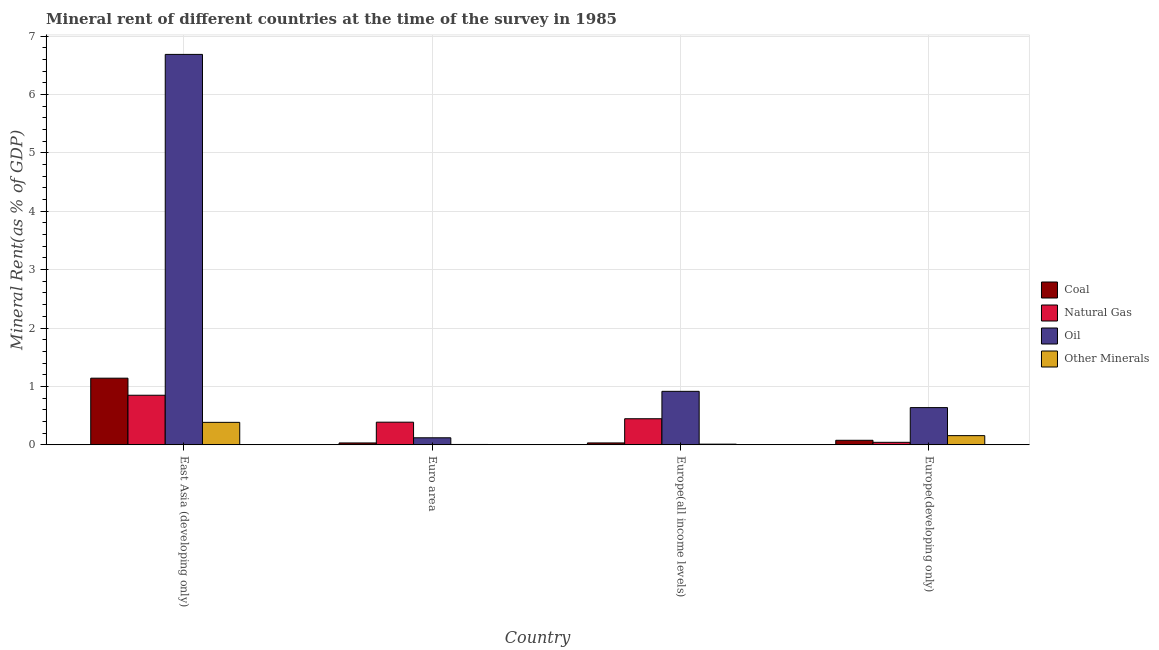How many different coloured bars are there?
Your answer should be compact. 4. How many bars are there on the 2nd tick from the left?
Your answer should be very brief. 4. How many bars are there on the 3rd tick from the right?
Provide a succinct answer. 4. What is the label of the 3rd group of bars from the left?
Ensure brevity in your answer.  Europe(all income levels). What is the oil rent in Europe(all income levels)?
Give a very brief answer. 0.92. Across all countries, what is the maximum  rent of other minerals?
Offer a very short reply. 0.38. Across all countries, what is the minimum oil rent?
Give a very brief answer. 0.12. In which country was the  rent of other minerals maximum?
Provide a succinct answer. East Asia (developing only). In which country was the  rent of other minerals minimum?
Keep it short and to the point. Euro area. What is the total natural gas rent in the graph?
Your answer should be very brief. 1.72. What is the difference between the coal rent in Euro area and that in Europe(developing only)?
Provide a short and direct response. -0.05. What is the difference between the oil rent in Euro area and the coal rent in Europe(all income levels)?
Offer a very short reply. 0.09. What is the average oil rent per country?
Your answer should be very brief. 2.09. What is the difference between the natural gas rent and  rent of other minerals in East Asia (developing only)?
Provide a short and direct response. 0.46. In how many countries, is the  rent of other minerals greater than 1 %?
Your answer should be compact. 0. What is the ratio of the oil rent in Europe(all income levels) to that in Europe(developing only)?
Keep it short and to the point. 1.44. Is the difference between the coal rent in East Asia (developing only) and Euro area greater than the difference between the natural gas rent in East Asia (developing only) and Euro area?
Your answer should be very brief. Yes. What is the difference between the highest and the second highest coal rent?
Give a very brief answer. 1.06. What is the difference between the highest and the lowest  rent of other minerals?
Make the answer very short. 0.38. In how many countries, is the  rent of other minerals greater than the average  rent of other minerals taken over all countries?
Offer a very short reply. 2. What does the 1st bar from the left in East Asia (developing only) represents?
Provide a succinct answer. Coal. What does the 3rd bar from the right in East Asia (developing only) represents?
Provide a short and direct response. Natural Gas. How many countries are there in the graph?
Provide a succinct answer. 4. Are the values on the major ticks of Y-axis written in scientific E-notation?
Ensure brevity in your answer.  No. Does the graph contain grids?
Offer a terse response. Yes. How many legend labels are there?
Offer a very short reply. 4. How are the legend labels stacked?
Offer a terse response. Vertical. What is the title of the graph?
Keep it short and to the point. Mineral rent of different countries at the time of the survey in 1985. Does "Gender equality" appear as one of the legend labels in the graph?
Your answer should be very brief. No. What is the label or title of the Y-axis?
Offer a terse response. Mineral Rent(as % of GDP). What is the Mineral Rent(as % of GDP) in Coal in East Asia (developing only)?
Provide a succinct answer. 1.14. What is the Mineral Rent(as % of GDP) of Natural Gas in East Asia (developing only)?
Provide a short and direct response. 0.85. What is the Mineral Rent(as % of GDP) in Oil in East Asia (developing only)?
Make the answer very short. 6.69. What is the Mineral Rent(as % of GDP) in Other Minerals in East Asia (developing only)?
Your answer should be compact. 0.38. What is the Mineral Rent(as % of GDP) of Coal in Euro area?
Your answer should be very brief. 0.03. What is the Mineral Rent(as % of GDP) in Natural Gas in Euro area?
Make the answer very short. 0.39. What is the Mineral Rent(as % of GDP) of Oil in Euro area?
Give a very brief answer. 0.12. What is the Mineral Rent(as % of GDP) in Other Minerals in Euro area?
Give a very brief answer. 0.01. What is the Mineral Rent(as % of GDP) in Coal in Europe(all income levels)?
Your response must be concise. 0.03. What is the Mineral Rent(as % of GDP) of Natural Gas in Europe(all income levels)?
Give a very brief answer. 0.45. What is the Mineral Rent(as % of GDP) in Oil in Europe(all income levels)?
Offer a very short reply. 0.92. What is the Mineral Rent(as % of GDP) in Other Minerals in Europe(all income levels)?
Offer a terse response. 0.01. What is the Mineral Rent(as % of GDP) of Coal in Europe(developing only)?
Offer a very short reply. 0.08. What is the Mineral Rent(as % of GDP) of Natural Gas in Europe(developing only)?
Offer a terse response. 0.04. What is the Mineral Rent(as % of GDP) in Oil in Europe(developing only)?
Make the answer very short. 0.64. What is the Mineral Rent(as % of GDP) in Other Minerals in Europe(developing only)?
Provide a succinct answer. 0.16. Across all countries, what is the maximum Mineral Rent(as % of GDP) of Coal?
Provide a succinct answer. 1.14. Across all countries, what is the maximum Mineral Rent(as % of GDP) of Natural Gas?
Give a very brief answer. 0.85. Across all countries, what is the maximum Mineral Rent(as % of GDP) of Oil?
Keep it short and to the point. 6.69. Across all countries, what is the maximum Mineral Rent(as % of GDP) in Other Minerals?
Your response must be concise. 0.38. Across all countries, what is the minimum Mineral Rent(as % of GDP) in Coal?
Provide a short and direct response. 0.03. Across all countries, what is the minimum Mineral Rent(as % of GDP) of Natural Gas?
Make the answer very short. 0.04. Across all countries, what is the minimum Mineral Rent(as % of GDP) of Oil?
Your answer should be very brief. 0.12. Across all countries, what is the minimum Mineral Rent(as % of GDP) in Other Minerals?
Provide a short and direct response. 0.01. What is the total Mineral Rent(as % of GDP) of Coal in the graph?
Provide a succinct answer. 1.28. What is the total Mineral Rent(as % of GDP) of Natural Gas in the graph?
Give a very brief answer. 1.72. What is the total Mineral Rent(as % of GDP) in Oil in the graph?
Provide a succinct answer. 8.36. What is the total Mineral Rent(as % of GDP) of Other Minerals in the graph?
Provide a short and direct response. 0.56. What is the difference between the Mineral Rent(as % of GDP) in Coal in East Asia (developing only) and that in Euro area?
Provide a succinct answer. 1.11. What is the difference between the Mineral Rent(as % of GDP) of Natural Gas in East Asia (developing only) and that in Euro area?
Your response must be concise. 0.46. What is the difference between the Mineral Rent(as % of GDP) of Oil in East Asia (developing only) and that in Euro area?
Keep it short and to the point. 6.57. What is the difference between the Mineral Rent(as % of GDP) in Other Minerals in East Asia (developing only) and that in Euro area?
Keep it short and to the point. 0.38. What is the difference between the Mineral Rent(as % of GDP) in Coal in East Asia (developing only) and that in Europe(all income levels)?
Provide a succinct answer. 1.11. What is the difference between the Mineral Rent(as % of GDP) of Natural Gas in East Asia (developing only) and that in Europe(all income levels)?
Your answer should be compact. 0.4. What is the difference between the Mineral Rent(as % of GDP) of Oil in East Asia (developing only) and that in Europe(all income levels)?
Give a very brief answer. 5.77. What is the difference between the Mineral Rent(as % of GDP) of Other Minerals in East Asia (developing only) and that in Europe(all income levels)?
Your answer should be compact. 0.37. What is the difference between the Mineral Rent(as % of GDP) of Coal in East Asia (developing only) and that in Europe(developing only)?
Your answer should be very brief. 1.06. What is the difference between the Mineral Rent(as % of GDP) in Natural Gas in East Asia (developing only) and that in Europe(developing only)?
Your response must be concise. 0.81. What is the difference between the Mineral Rent(as % of GDP) of Oil in East Asia (developing only) and that in Europe(developing only)?
Keep it short and to the point. 6.05. What is the difference between the Mineral Rent(as % of GDP) in Other Minerals in East Asia (developing only) and that in Europe(developing only)?
Your answer should be compact. 0.23. What is the difference between the Mineral Rent(as % of GDP) of Coal in Euro area and that in Europe(all income levels)?
Ensure brevity in your answer.  -0. What is the difference between the Mineral Rent(as % of GDP) in Natural Gas in Euro area and that in Europe(all income levels)?
Give a very brief answer. -0.06. What is the difference between the Mineral Rent(as % of GDP) of Oil in Euro area and that in Europe(all income levels)?
Keep it short and to the point. -0.8. What is the difference between the Mineral Rent(as % of GDP) of Other Minerals in Euro area and that in Europe(all income levels)?
Provide a short and direct response. -0.01. What is the difference between the Mineral Rent(as % of GDP) of Coal in Euro area and that in Europe(developing only)?
Your answer should be very brief. -0.05. What is the difference between the Mineral Rent(as % of GDP) of Natural Gas in Euro area and that in Europe(developing only)?
Provide a succinct answer. 0.34. What is the difference between the Mineral Rent(as % of GDP) in Oil in Euro area and that in Europe(developing only)?
Provide a succinct answer. -0.52. What is the difference between the Mineral Rent(as % of GDP) in Other Minerals in Euro area and that in Europe(developing only)?
Your answer should be compact. -0.15. What is the difference between the Mineral Rent(as % of GDP) of Coal in Europe(all income levels) and that in Europe(developing only)?
Provide a succinct answer. -0.05. What is the difference between the Mineral Rent(as % of GDP) of Natural Gas in Europe(all income levels) and that in Europe(developing only)?
Your answer should be very brief. 0.4. What is the difference between the Mineral Rent(as % of GDP) of Oil in Europe(all income levels) and that in Europe(developing only)?
Offer a very short reply. 0.28. What is the difference between the Mineral Rent(as % of GDP) of Other Minerals in Europe(all income levels) and that in Europe(developing only)?
Your answer should be compact. -0.15. What is the difference between the Mineral Rent(as % of GDP) in Coal in East Asia (developing only) and the Mineral Rent(as % of GDP) in Natural Gas in Euro area?
Your answer should be compact. 0.75. What is the difference between the Mineral Rent(as % of GDP) in Coal in East Asia (developing only) and the Mineral Rent(as % of GDP) in Oil in Euro area?
Ensure brevity in your answer.  1.02. What is the difference between the Mineral Rent(as % of GDP) in Coal in East Asia (developing only) and the Mineral Rent(as % of GDP) in Other Minerals in Euro area?
Make the answer very short. 1.13. What is the difference between the Mineral Rent(as % of GDP) in Natural Gas in East Asia (developing only) and the Mineral Rent(as % of GDP) in Oil in Euro area?
Give a very brief answer. 0.73. What is the difference between the Mineral Rent(as % of GDP) of Natural Gas in East Asia (developing only) and the Mineral Rent(as % of GDP) of Other Minerals in Euro area?
Your answer should be very brief. 0.84. What is the difference between the Mineral Rent(as % of GDP) in Oil in East Asia (developing only) and the Mineral Rent(as % of GDP) in Other Minerals in Euro area?
Your answer should be compact. 6.68. What is the difference between the Mineral Rent(as % of GDP) of Coal in East Asia (developing only) and the Mineral Rent(as % of GDP) of Natural Gas in Europe(all income levels)?
Your answer should be very brief. 0.69. What is the difference between the Mineral Rent(as % of GDP) of Coal in East Asia (developing only) and the Mineral Rent(as % of GDP) of Oil in Europe(all income levels)?
Offer a very short reply. 0.23. What is the difference between the Mineral Rent(as % of GDP) of Coal in East Asia (developing only) and the Mineral Rent(as % of GDP) of Other Minerals in Europe(all income levels)?
Provide a short and direct response. 1.13. What is the difference between the Mineral Rent(as % of GDP) in Natural Gas in East Asia (developing only) and the Mineral Rent(as % of GDP) in Oil in Europe(all income levels)?
Ensure brevity in your answer.  -0.07. What is the difference between the Mineral Rent(as % of GDP) in Natural Gas in East Asia (developing only) and the Mineral Rent(as % of GDP) in Other Minerals in Europe(all income levels)?
Provide a succinct answer. 0.84. What is the difference between the Mineral Rent(as % of GDP) of Oil in East Asia (developing only) and the Mineral Rent(as % of GDP) of Other Minerals in Europe(all income levels)?
Your answer should be very brief. 6.67. What is the difference between the Mineral Rent(as % of GDP) of Coal in East Asia (developing only) and the Mineral Rent(as % of GDP) of Natural Gas in Europe(developing only)?
Offer a very short reply. 1.1. What is the difference between the Mineral Rent(as % of GDP) in Coal in East Asia (developing only) and the Mineral Rent(as % of GDP) in Oil in Europe(developing only)?
Ensure brevity in your answer.  0.5. What is the difference between the Mineral Rent(as % of GDP) of Coal in East Asia (developing only) and the Mineral Rent(as % of GDP) of Other Minerals in Europe(developing only)?
Offer a very short reply. 0.98. What is the difference between the Mineral Rent(as % of GDP) of Natural Gas in East Asia (developing only) and the Mineral Rent(as % of GDP) of Oil in Europe(developing only)?
Your answer should be very brief. 0.21. What is the difference between the Mineral Rent(as % of GDP) in Natural Gas in East Asia (developing only) and the Mineral Rent(as % of GDP) in Other Minerals in Europe(developing only)?
Give a very brief answer. 0.69. What is the difference between the Mineral Rent(as % of GDP) of Oil in East Asia (developing only) and the Mineral Rent(as % of GDP) of Other Minerals in Europe(developing only)?
Provide a short and direct response. 6.53. What is the difference between the Mineral Rent(as % of GDP) in Coal in Euro area and the Mineral Rent(as % of GDP) in Natural Gas in Europe(all income levels)?
Your answer should be compact. -0.41. What is the difference between the Mineral Rent(as % of GDP) in Coal in Euro area and the Mineral Rent(as % of GDP) in Oil in Europe(all income levels)?
Ensure brevity in your answer.  -0.88. What is the difference between the Mineral Rent(as % of GDP) in Coal in Euro area and the Mineral Rent(as % of GDP) in Other Minerals in Europe(all income levels)?
Your response must be concise. 0.02. What is the difference between the Mineral Rent(as % of GDP) of Natural Gas in Euro area and the Mineral Rent(as % of GDP) of Oil in Europe(all income levels)?
Offer a very short reply. -0.53. What is the difference between the Mineral Rent(as % of GDP) of Natural Gas in Euro area and the Mineral Rent(as % of GDP) of Other Minerals in Europe(all income levels)?
Keep it short and to the point. 0.38. What is the difference between the Mineral Rent(as % of GDP) of Oil in Euro area and the Mineral Rent(as % of GDP) of Other Minerals in Europe(all income levels)?
Your answer should be compact. 0.11. What is the difference between the Mineral Rent(as % of GDP) of Coal in Euro area and the Mineral Rent(as % of GDP) of Natural Gas in Europe(developing only)?
Ensure brevity in your answer.  -0.01. What is the difference between the Mineral Rent(as % of GDP) in Coal in Euro area and the Mineral Rent(as % of GDP) in Oil in Europe(developing only)?
Your answer should be very brief. -0.61. What is the difference between the Mineral Rent(as % of GDP) of Coal in Euro area and the Mineral Rent(as % of GDP) of Other Minerals in Europe(developing only)?
Your answer should be compact. -0.13. What is the difference between the Mineral Rent(as % of GDP) in Natural Gas in Euro area and the Mineral Rent(as % of GDP) in Oil in Europe(developing only)?
Your response must be concise. -0.25. What is the difference between the Mineral Rent(as % of GDP) of Natural Gas in Euro area and the Mineral Rent(as % of GDP) of Other Minerals in Europe(developing only)?
Ensure brevity in your answer.  0.23. What is the difference between the Mineral Rent(as % of GDP) of Oil in Euro area and the Mineral Rent(as % of GDP) of Other Minerals in Europe(developing only)?
Keep it short and to the point. -0.04. What is the difference between the Mineral Rent(as % of GDP) in Coal in Europe(all income levels) and the Mineral Rent(as % of GDP) in Natural Gas in Europe(developing only)?
Give a very brief answer. -0.01. What is the difference between the Mineral Rent(as % of GDP) of Coal in Europe(all income levels) and the Mineral Rent(as % of GDP) of Oil in Europe(developing only)?
Your answer should be compact. -0.6. What is the difference between the Mineral Rent(as % of GDP) in Coal in Europe(all income levels) and the Mineral Rent(as % of GDP) in Other Minerals in Europe(developing only)?
Provide a succinct answer. -0.13. What is the difference between the Mineral Rent(as % of GDP) in Natural Gas in Europe(all income levels) and the Mineral Rent(as % of GDP) in Oil in Europe(developing only)?
Give a very brief answer. -0.19. What is the difference between the Mineral Rent(as % of GDP) of Natural Gas in Europe(all income levels) and the Mineral Rent(as % of GDP) of Other Minerals in Europe(developing only)?
Keep it short and to the point. 0.29. What is the difference between the Mineral Rent(as % of GDP) in Oil in Europe(all income levels) and the Mineral Rent(as % of GDP) in Other Minerals in Europe(developing only)?
Give a very brief answer. 0.76. What is the average Mineral Rent(as % of GDP) in Coal per country?
Your response must be concise. 0.32. What is the average Mineral Rent(as % of GDP) in Natural Gas per country?
Ensure brevity in your answer.  0.43. What is the average Mineral Rent(as % of GDP) in Oil per country?
Offer a terse response. 2.09. What is the average Mineral Rent(as % of GDP) of Other Minerals per country?
Give a very brief answer. 0.14. What is the difference between the Mineral Rent(as % of GDP) of Coal and Mineral Rent(as % of GDP) of Natural Gas in East Asia (developing only)?
Your answer should be very brief. 0.29. What is the difference between the Mineral Rent(as % of GDP) of Coal and Mineral Rent(as % of GDP) of Oil in East Asia (developing only)?
Provide a succinct answer. -5.54. What is the difference between the Mineral Rent(as % of GDP) of Coal and Mineral Rent(as % of GDP) of Other Minerals in East Asia (developing only)?
Your answer should be very brief. 0.76. What is the difference between the Mineral Rent(as % of GDP) of Natural Gas and Mineral Rent(as % of GDP) of Oil in East Asia (developing only)?
Your answer should be very brief. -5.84. What is the difference between the Mineral Rent(as % of GDP) of Natural Gas and Mineral Rent(as % of GDP) of Other Minerals in East Asia (developing only)?
Provide a succinct answer. 0.46. What is the difference between the Mineral Rent(as % of GDP) of Oil and Mineral Rent(as % of GDP) of Other Minerals in East Asia (developing only)?
Offer a terse response. 6.3. What is the difference between the Mineral Rent(as % of GDP) of Coal and Mineral Rent(as % of GDP) of Natural Gas in Euro area?
Give a very brief answer. -0.36. What is the difference between the Mineral Rent(as % of GDP) of Coal and Mineral Rent(as % of GDP) of Oil in Euro area?
Your response must be concise. -0.09. What is the difference between the Mineral Rent(as % of GDP) in Coal and Mineral Rent(as % of GDP) in Other Minerals in Euro area?
Give a very brief answer. 0.03. What is the difference between the Mineral Rent(as % of GDP) in Natural Gas and Mineral Rent(as % of GDP) in Oil in Euro area?
Give a very brief answer. 0.27. What is the difference between the Mineral Rent(as % of GDP) in Natural Gas and Mineral Rent(as % of GDP) in Other Minerals in Euro area?
Your answer should be very brief. 0.38. What is the difference between the Mineral Rent(as % of GDP) in Oil and Mineral Rent(as % of GDP) in Other Minerals in Euro area?
Provide a succinct answer. 0.11. What is the difference between the Mineral Rent(as % of GDP) in Coal and Mineral Rent(as % of GDP) in Natural Gas in Europe(all income levels)?
Your answer should be compact. -0.41. What is the difference between the Mineral Rent(as % of GDP) of Coal and Mineral Rent(as % of GDP) of Oil in Europe(all income levels)?
Your answer should be very brief. -0.88. What is the difference between the Mineral Rent(as % of GDP) in Coal and Mineral Rent(as % of GDP) in Other Minerals in Europe(all income levels)?
Your answer should be very brief. 0.02. What is the difference between the Mineral Rent(as % of GDP) of Natural Gas and Mineral Rent(as % of GDP) of Oil in Europe(all income levels)?
Offer a very short reply. -0.47. What is the difference between the Mineral Rent(as % of GDP) in Natural Gas and Mineral Rent(as % of GDP) in Other Minerals in Europe(all income levels)?
Keep it short and to the point. 0.44. What is the difference between the Mineral Rent(as % of GDP) of Oil and Mineral Rent(as % of GDP) of Other Minerals in Europe(all income levels)?
Offer a terse response. 0.9. What is the difference between the Mineral Rent(as % of GDP) of Coal and Mineral Rent(as % of GDP) of Natural Gas in Europe(developing only)?
Make the answer very short. 0.03. What is the difference between the Mineral Rent(as % of GDP) in Coal and Mineral Rent(as % of GDP) in Oil in Europe(developing only)?
Ensure brevity in your answer.  -0.56. What is the difference between the Mineral Rent(as % of GDP) of Coal and Mineral Rent(as % of GDP) of Other Minerals in Europe(developing only)?
Ensure brevity in your answer.  -0.08. What is the difference between the Mineral Rent(as % of GDP) in Natural Gas and Mineral Rent(as % of GDP) in Oil in Europe(developing only)?
Provide a succinct answer. -0.59. What is the difference between the Mineral Rent(as % of GDP) of Natural Gas and Mineral Rent(as % of GDP) of Other Minerals in Europe(developing only)?
Your answer should be very brief. -0.11. What is the difference between the Mineral Rent(as % of GDP) of Oil and Mineral Rent(as % of GDP) of Other Minerals in Europe(developing only)?
Make the answer very short. 0.48. What is the ratio of the Mineral Rent(as % of GDP) of Coal in East Asia (developing only) to that in Euro area?
Ensure brevity in your answer.  36.03. What is the ratio of the Mineral Rent(as % of GDP) in Natural Gas in East Asia (developing only) to that in Euro area?
Your response must be concise. 2.19. What is the ratio of the Mineral Rent(as % of GDP) of Oil in East Asia (developing only) to that in Euro area?
Ensure brevity in your answer.  55.65. What is the ratio of the Mineral Rent(as % of GDP) in Other Minerals in East Asia (developing only) to that in Euro area?
Ensure brevity in your answer.  65.82. What is the ratio of the Mineral Rent(as % of GDP) of Coal in East Asia (developing only) to that in Europe(all income levels)?
Your answer should be compact. 35.66. What is the ratio of the Mineral Rent(as % of GDP) in Natural Gas in East Asia (developing only) to that in Europe(all income levels)?
Keep it short and to the point. 1.9. What is the ratio of the Mineral Rent(as % of GDP) in Oil in East Asia (developing only) to that in Europe(all income levels)?
Your answer should be very brief. 7.3. What is the ratio of the Mineral Rent(as % of GDP) of Other Minerals in East Asia (developing only) to that in Europe(all income levels)?
Offer a terse response. 34.87. What is the ratio of the Mineral Rent(as % of GDP) of Coal in East Asia (developing only) to that in Europe(developing only)?
Keep it short and to the point. 14.76. What is the ratio of the Mineral Rent(as % of GDP) of Natural Gas in East Asia (developing only) to that in Europe(developing only)?
Offer a terse response. 20. What is the ratio of the Mineral Rent(as % of GDP) in Oil in East Asia (developing only) to that in Europe(developing only)?
Offer a terse response. 10.5. What is the ratio of the Mineral Rent(as % of GDP) of Other Minerals in East Asia (developing only) to that in Europe(developing only)?
Give a very brief answer. 2.45. What is the ratio of the Mineral Rent(as % of GDP) in Natural Gas in Euro area to that in Europe(all income levels)?
Ensure brevity in your answer.  0.87. What is the ratio of the Mineral Rent(as % of GDP) in Oil in Euro area to that in Europe(all income levels)?
Your answer should be very brief. 0.13. What is the ratio of the Mineral Rent(as % of GDP) in Other Minerals in Euro area to that in Europe(all income levels)?
Offer a very short reply. 0.53. What is the ratio of the Mineral Rent(as % of GDP) in Coal in Euro area to that in Europe(developing only)?
Give a very brief answer. 0.41. What is the ratio of the Mineral Rent(as % of GDP) of Natural Gas in Euro area to that in Europe(developing only)?
Ensure brevity in your answer.  9.13. What is the ratio of the Mineral Rent(as % of GDP) of Oil in Euro area to that in Europe(developing only)?
Offer a very short reply. 0.19. What is the ratio of the Mineral Rent(as % of GDP) in Other Minerals in Euro area to that in Europe(developing only)?
Your response must be concise. 0.04. What is the ratio of the Mineral Rent(as % of GDP) of Coal in Europe(all income levels) to that in Europe(developing only)?
Give a very brief answer. 0.41. What is the ratio of the Mineral Rent(as % of GDP) in Natural Gas in Europe(all income levels) to that in Europe(developing only)?
Keep it short and to the point. 10.52. What is the ratio of the Mineral Rent(as % of GDP) of Oil in Europe(all income levels) to that in Europe(developing only)?
Offer a terse response. 1.44. What is the ratio of the Mineral Rent(as % of GDP) of Other Minerals in Europe(all income levels) to that in Europe(developing only)?
Ensure brevity in your answer.  0.07. What is the difference between the highest and the second highest Mineral Rent(as % of GDP) of Coal?
Make the answer very short. 1.06. What is the difference between the highest and the second highest Mineral Rent(as % of GDP) of Natural Gas?
Your response must be concise. 0.4. What is the difference between the highest and the second highest Mineral Rent(as % of GDP) in Oil?
Offer a terse response. 5.77. What is the difference between the highest and the second highest Mineral Rent(as % of GDP) of Other Minerals?
Make the answer very short. 0.23. What is the difference between the highest and the lowest Mineral Rent(as % of GDP) of Coal?
Provide a succinct answer. 1.11. What is the difference between the highest and the lowest Mineral Rent(as % of GDP) of Natural Gas?
Provide a short and direct response. 0.81. What is the difference between the highest and the lowest Mineral Rent(as % of GDP) of Oil?
Your answer should be very brief. 6.57. What is the difference between the highest and the lowest Mineral Rent(as % of GDP) in Other Minerals?
Offer a very short reply. 0.38. 